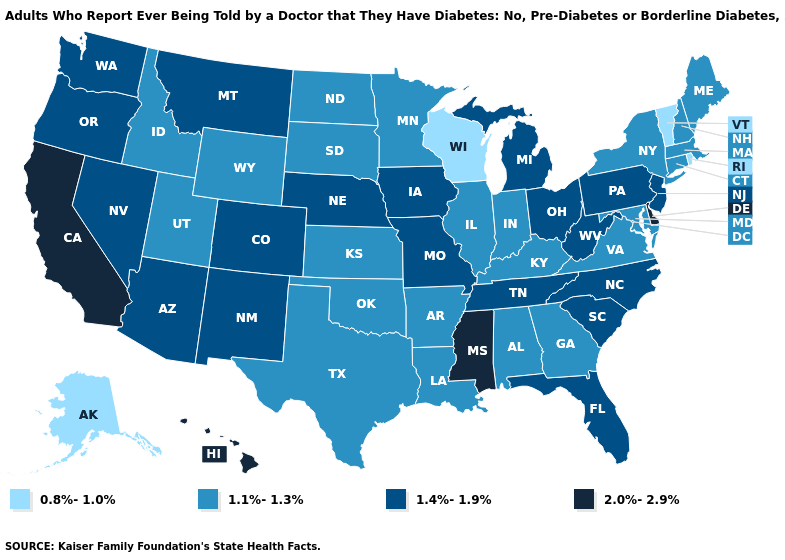What is the highest value in states that border Colorado?
Be succinct. 1.4%-1.9%. What is the value of Arkansas?
Keep it brief. 1.1%-1.3%. What is the lowest value in the USA?
Write a very short answer. 0.8%-1.0%. Name the states that have a value in the range 0.8%-1.0%?
Answer briefly. Alaska, Rhode Island, Vermont, Wisconsin. Which states have the lowest value in the USA?
Answer briefly. Alaska, Rhode Island, Vermont, Wisconsin. Which states have the lowest value in the West?
Give a very brief answer. Alaska. Does North Carolina have the highest value in the South?
Concise answer only. No. Does New Jersey have the highest value in the Northeast?
Give a very brief answer. Yes. What is the value of California?
Concise answer only. 2.0%-2.9%. Does California have the highest value in the USA?
Write a very short answer. Yes. Does Colorado have the same value as New Mexico?
Concise answer only. Yes. Name the states that have a value in the range 1.1%-1.3%?
Give a very brief answer. Alabama, Arkansas, Connecticut, Georgia, Idaho, Illinois, Indiana, Kansas, Kentucky, Louisiana, Maine, Maryland, Massachusetts, Minnesota, New Hampshire, New York, North Dakota, Oklahoma, South Dakota, Texas, Utah, Virginia, Wyoming. Among the states that border Michigan , does Ohio have the highest value?
Short answer required. Yes. Name the states that have a value in the range 1.1%-1.3%?
Quick response, please. Alabama, Arkansas, Connecticut, Georgia, Idaho, Illinois, Indiana, Kansas, Kentucky, Louisiana, Maine, Maryland, Massachusetts, Minnesota, New Hampshire, New York, North Dakota, Oklahoma, South Dakota, Texas, Utah, Virginia, Wyoming. Does South Carolina have a higher value than Oregon?
Write a very short answer. No. 